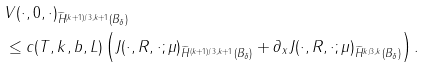<formula> <loc_0><loc_0><loc_500><loc_500>& \| V ( \cdot , 0 , \cdot ) \| _ { \widetilde { H } ^ { ( k + 1 ) / 3 , k + 1 } ( B _ { \delta } ) } \\ & \leq c ( T , k , b , L ) \left ( \| J ( \cdot , R , \cdot ; \mu ) \| _ { \widetilde { H } ^ { ( k + 1 ) / 3 , k + 1 } ( B _ { \delta } ) } + \| \partial _ { x } J ( \cdot , R , \cdot ; \mu ) \| _ { \widetilde { H } ^ { k / 3 , k } ( B _ { \delta } ) } \right ) .</formula> 